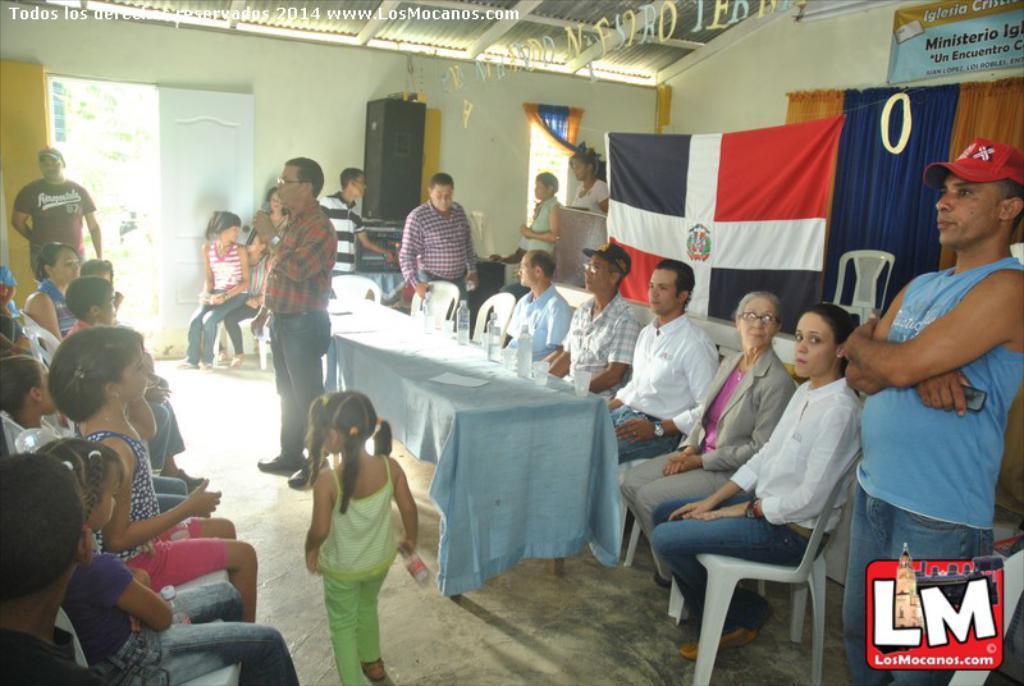Could you give a brief overview of what you see in this image? This picture is clicked inside. In the center we can see the group of persons sitting on the chairs and we can see the group of people standing on the ground. In the foreground there is a girl holding an object and walking on the ground and we can see a person holding a microphone and standing on the ground and there is a table on the top of which paper, glasses and water bottles are placed. At the top there is a roof. In the background we can see the wall, banner on with the text and we can see the curtains, window, flag and a door and some other items and we can see the text on the image. 